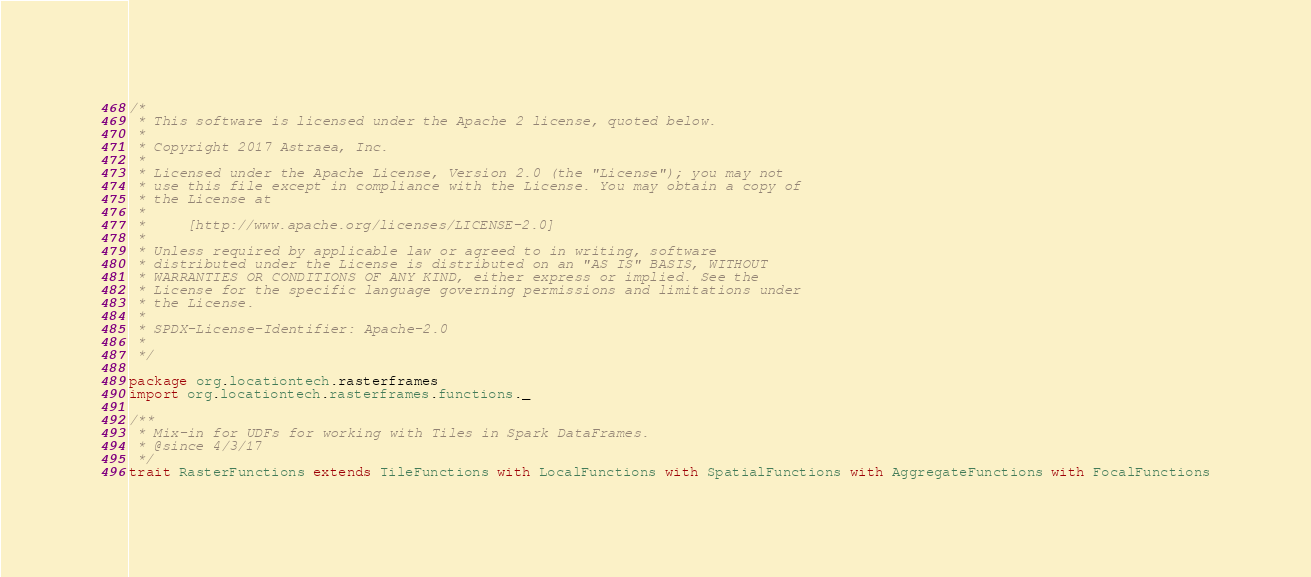<code> <loc_0><loc_0><loc_500><loc_500><_Scala_>/*
 * This software is licensed under the Apache 2 license, quoted below.
 *
 * Copyright 2017 Astraea, Inc.
 *
 * Licensed under the Apache License, Version 2.0 (the "License"); you may not
 * use this file except in compliance with the License. You may obtain a copy of
 * the License at
 *
 *     [http://www.apache.org/licenses/LICENSE-2.0]
 *
 * Unless required by applicable law or agreed to in writing, software
 * distributed under the License is distributed on an "AS IS" BASIS, WITHOUT
 * WARRANTIES OR CONDITIONS OF ANY KIND, either express or implied. See the
 * License for the specific language governing permissions and limitations under
 * the License.
 *
 * SPDX-License-Identifier: Apache-2.0
 *
 */

package org.locationtech.rasterframes
import org.locationtech.rasterframes.functions._

/**
 * Mix-in for UDFs for working with Tiles in Spark DataFrames.
 * @since 4/3/17
 */
trait RasterFunctions extends TileFunctions with LocalFunctions with SpatialFunctions with AggregateFunctions with FocalFunctions
</code> 